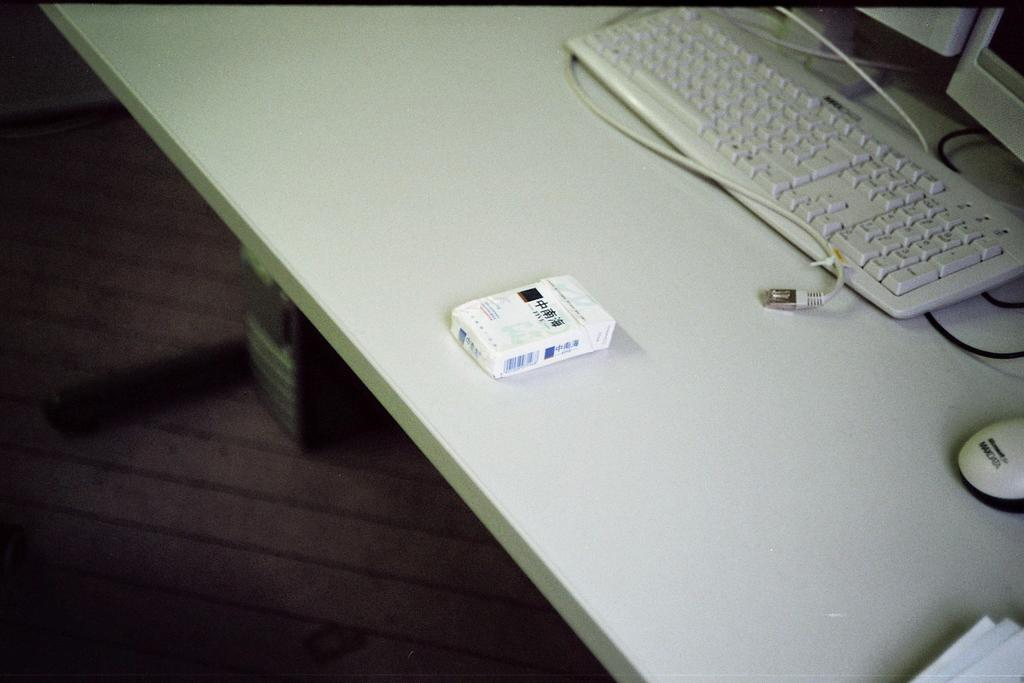<image>
Offer a succinct explanation of the picture presented. A pack of cigarettes with three chinese characters is on a table in front of the keyboard. 